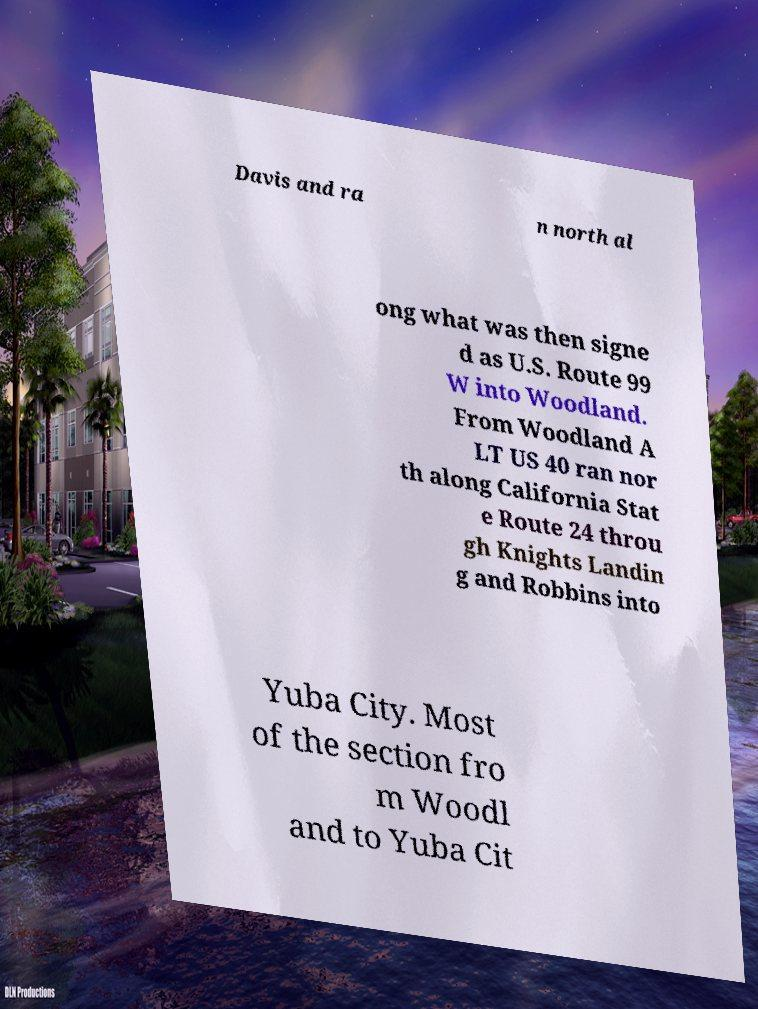Could you assist in decoding the text presented in this image and type it out clearly? Davis and ra n north al ong what was then signe d as U.S. Route 99 W into Woodland. From Woodland A LT US 40 ran nor th along California Stat e Route 24 throu gh Knights Landin g and Robbins into Yuba City. Most of the section fro m Woodl and to Yuba Cit 